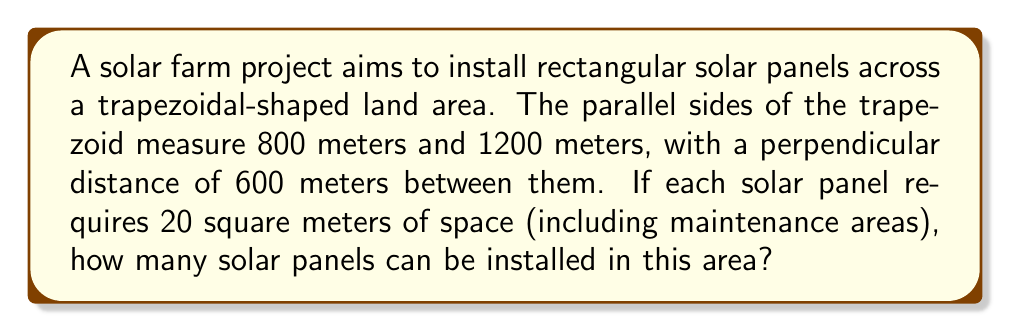Provide a solution to this math problem. To solve this problem, we need to follow these steps:

1. Calculate the area of the trapezoidal land:
   The formula for the area of a trapezoid is:
   $$A = \frac{1}{2}(b_1 + b_2)h$$
   where $b_1$ and $b_2$ are the parallel sides, and $h$ is the height.

   Substituting the given values:
   $$A = \frac{1}{2}(800 \text{ m} + 1200 \text{ m}) \times 600 \text{ m}$$
   $$A = \frac{1}{2}(2000 \text{ m}) \times 600 \text{ m}$$
   $$A = 1000 \text{ m} \times 600 \text{ m}$$
   $$A = 600,000 \text{ m}^2$$

2. Calculate the number of solar panels that can fit in this area:
   Each solar panel requires 20 square meters of space.
   Number of panels = Total area ÷ Area per panel
   $$\text{Number of panels} = \frac{600,000 \text{ m}^2}{20 \text{ m}^2/\text{panel}}$$
   $$\text{Number of panels} = 30,000$$

Therefore, 30,000 solar panels can be installed in this trapezoidal area.
Answer: 30,000 solar panels 